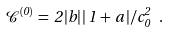<formula> <loc_0><loc_0><loc_500><loc_500>\mathcal { C } ^ { ( 0 ) } \, = \, 2 \, | b | \, | \, 1 \, + \, a \, | / c _ { 0 } ^ { 2 } \ .</formula> 